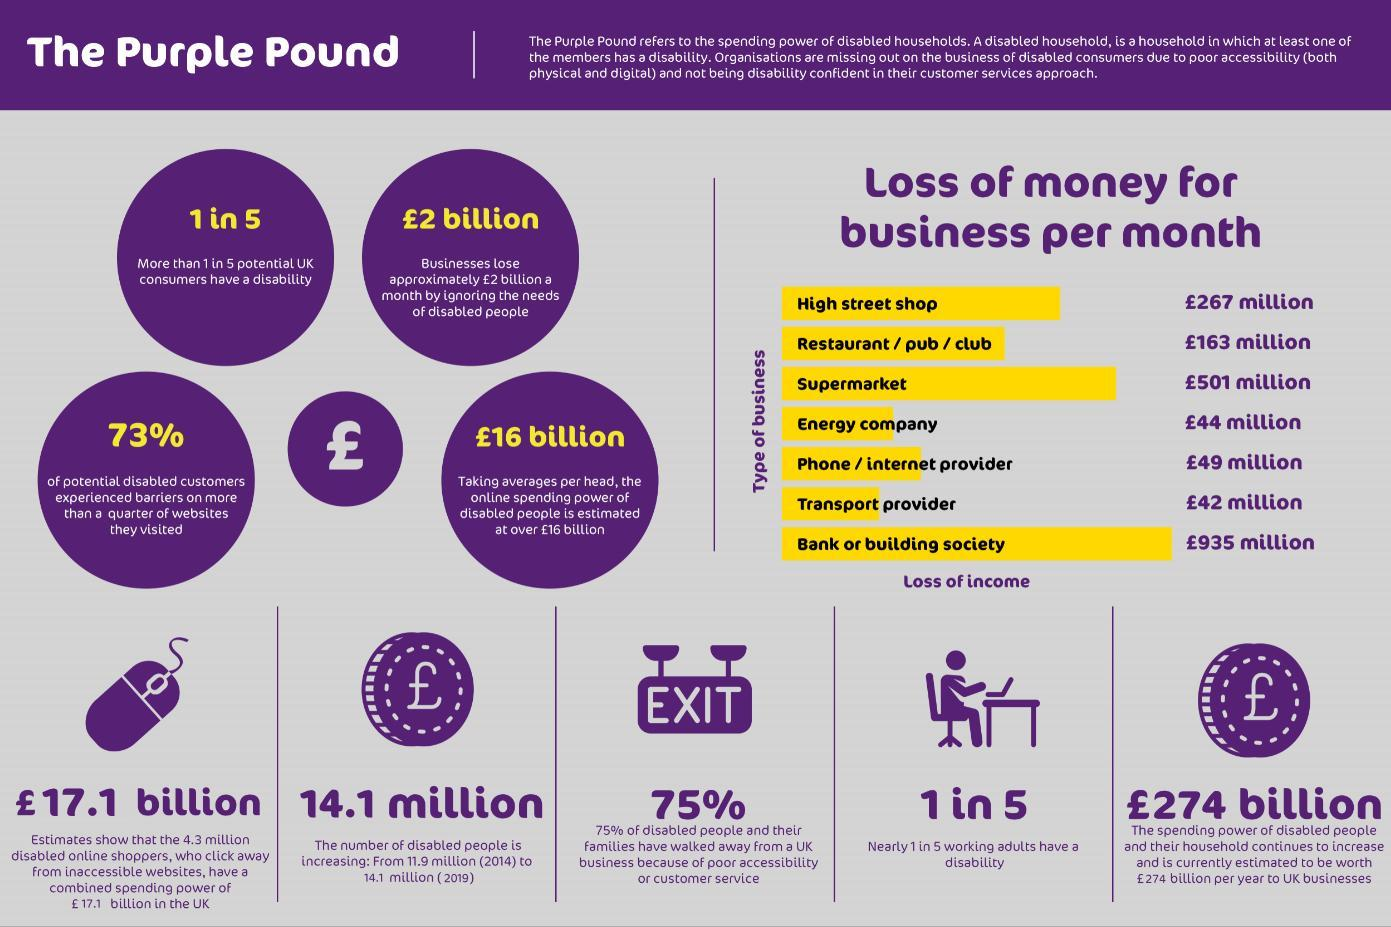What percentage of UK consumers have a disability ?
Answer the question with a short phrase. 20% From among the seven types of business shown, which one is the most disabled-friendly ? Transport provider What is the 'average' online spending capacity of the disabled (in pounds) ? 16 billion In every 5 UK consumers, how many are disabled ? 1 How much more is the loss of income, of an energy company than that of a transport provider (in million pounds)? 2 What is the increase in the number of disabled people between 2014 and 2019 (in milion)? 2.2 Which type of business incurs the highest amount of loss due to not being disabled-friendly ? Bank or building society How many types of businesses have loss of income ignoring the needs of the disabled ? 7 